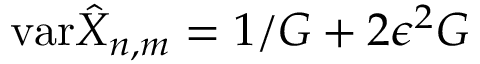Convert formula to latex. <formula><loc_0><loc_0><loc_500><loc_500>v a r \hat { X } _ { n , m } = 1 / G + 2 \epsilon ^ { 2 } G</formula> 